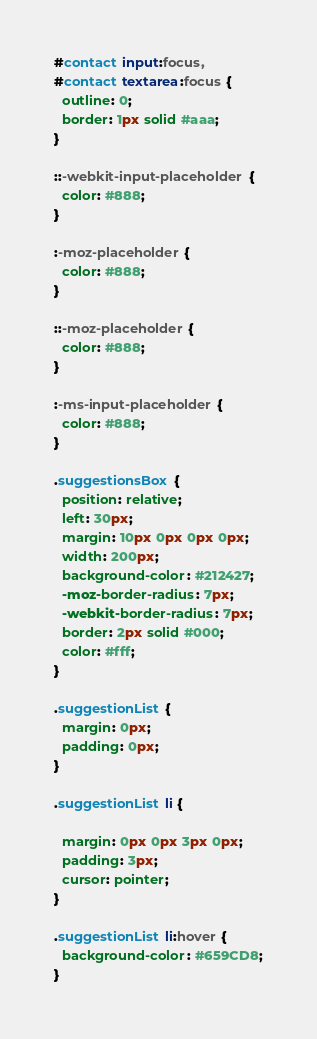<code> <loc_0><loc_0><loc_500><loc_500><_CSS_>#contact input:focus,
#contact textarea:focus {
  outline: 0;
  border: 1px solid #aaa;
}

::-webkit-input-placeholder {
  color: #888;
}

:-moz-placeholder {
  color: #888;
}

::-moz-placeholder {
  color: #888;
}

:-ms-input-placeholder {
  color: #888;
}

.suggestionsBox {
  position: relative;
  left: 30px;
  margin: 10px 0px 0px 0px;
  width: 200px;
  background-color: #212427;
  -moz-border-radius: 7px;
  -webkit-border-radius: 7px;
  border: 2px solid #000;
  color: #fff;
}

.suggestionList {
  margin: 0px;
  padding: 0px;
}

.suggestionList li {

  margin: 0px 0px 3px 0px;
  padding: 3px;
  cursor: pointer;
}

.suggestionList li:hover {
  background-color: #659CD8;
}
</code> 